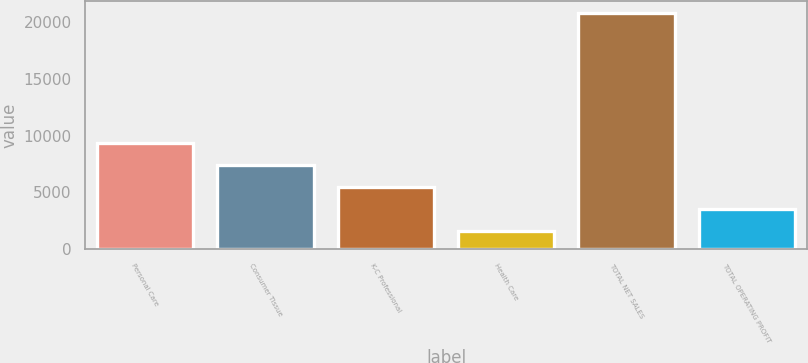<chart> <loc_0><loc_0><loc_500><loc_500><bar_chart><fcel>Personal Care<fcel>Consumer Tissue<fcel>K-C Professional<fcel>Health Care<fcel>TOTAL NET SALES<fcel>TOTAL OPERATING PROFIT<nl><fcel>9302<fcel>7378<fcel>5454<fcel>1606<fcel>20846<fcel>3530<nl></chart> 